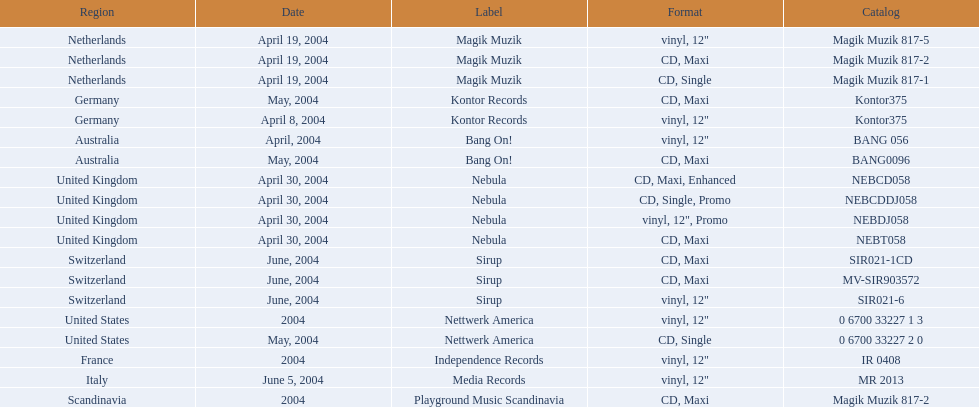What tag was employed by the netherlands in love comes again? Magik Muzik. What tag was employed in germany? Kontor Records. What tag was employed in france? Independence Records. 